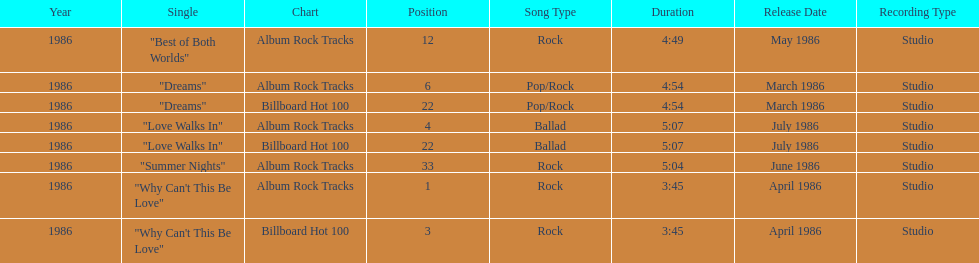Which singles each appear at position 22? Dreams, Love Walks In. 